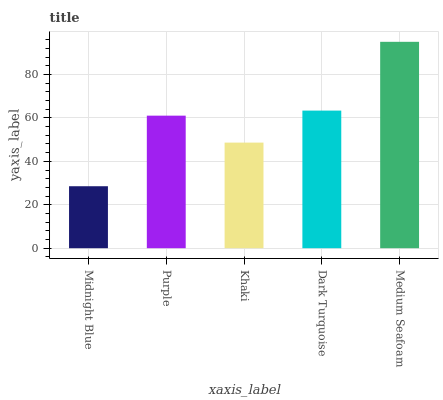Is Midnight Blue the minimum?
Answer yes or no. Yes. Is Medium Seafoam the maximum?
Answer yes or no. Yes. Is Purple the minimum?
Answer yes or no. No. Is Purple the maximum?
Answer yes or no. No. Is Purple greater than Midnight Blue?
Answer yes or no. Yes. Is Midnight Blue less than Purple?
Answer yes or no. Yes. Is Midnight Blue greater than Purple?
Answer yes or no. No. Is Purple less than Midnight Blue?
Answer yes or no. No. Is Purple the high median?
Answer yes or no. Yes. Is Purple the low median?
Answer yes or no. Yes. Is Midnight Blue the high median?
Answer yes or no. No. Is Medium Seafoam the low median?
Answer yes or no. No. 